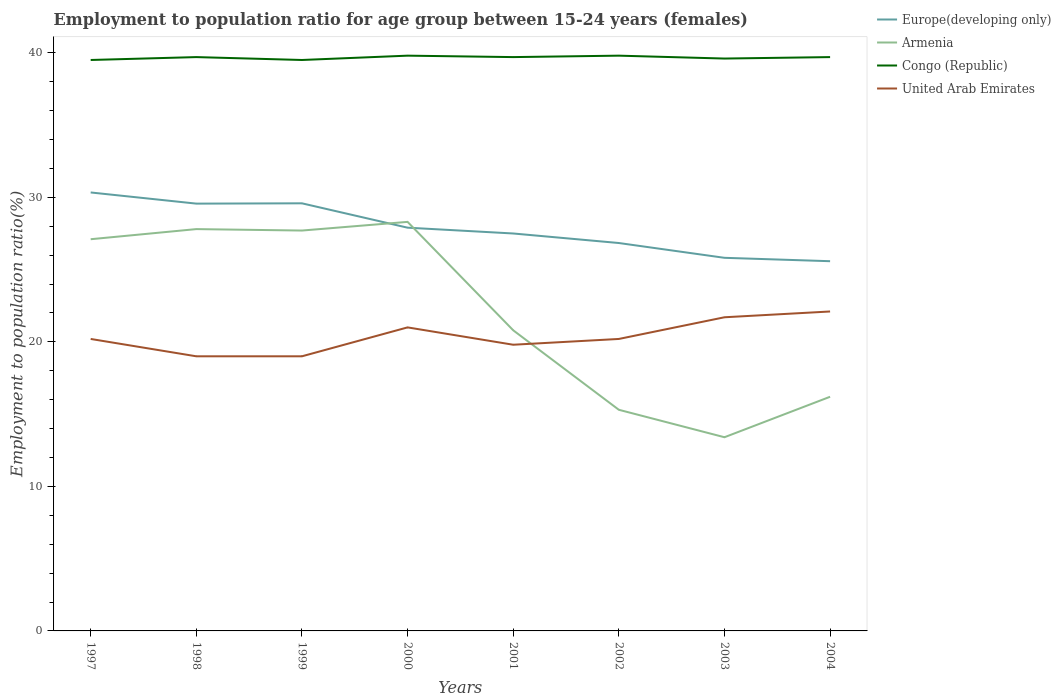How many different coloured lines are there?
Keep it short and to the point. 4. Is the number of lines equal to the number of legend labels?
Offer a terse response. Yes. Across all years, what is the maximum employment to population ratio in Armenia?
Keep it short and to the point. 13.4. What is the total employment to population ratio in Armenia in the graph?
Your answer should be very brief. 11.8. What is the difference between the highest and the second highest employment to population ratio in Europe(developing only)?
Keep it short and to the point. 4.76. How many lines are there?
Give a very brief answer. 4. Are the values on the major ticks of Y-axis written in scientific E-notation?
Offer a very short reply. No. How many legend labels are there?
Your answer should be compact. 4. What is the title of the graph?
Give a very brief answer. Employment to population ratio for age group between 15-24 years (females). Does "Seychelles" appear as one of the legend labels in the graph?
Provide a succinct answer. No. What is the label or title of the Y-axis?
Keep it short and to the point. Employment to population ratio(%). What is the Employment to population ratio(%) in Europe(developing only) in 1997?
Offer a very short reply. 30.33. What is the Employment to population ratio(%) of Armenia in 1997?
Keep it short and to the point. 27.1. What is the Employment to population ratio(%) in Congo (Republic) in 1997?
Provide a short and direct response. 39.5. What is the Employment to population ratio(%) of United Arab Emirates in 1997?
Your answer should be compact. 20.2. What is the Employment to population ratio(%) of Europe(developing only) in 1998?
Ensure brevity in your answer.  29.56. What is the Employment to population ratio(%) in Armenia in 1998?
Provide a succinct answer. 27.8. What is the Employment to population ratio(%) of Congo (Republic) in 1998?
Give a very brief answer. 39.7. What is the Employment to population ratio(%) of United Arab Emirates in 1998?
Provide a short and direct response. 19. What is the Employment to population ratio(%) of Europe(developing only) in 1999?
Make the answer very short. 29.58. What is the Employment to population ratio(%) in Armenia in 1999?
Your response must be concise. 27.7. What is the Employment to population ratio(%) of Congo (Republic) in 1999?
Give a very brief answer. 39.5. What is the Employment to population ratio(%) in Europe(developing only) in 2000?
Your answer should be very brief. 27.9. What is the Employment to population ratio(%) of Armenia in 2000?
Offer a very short reply. 28.3. What is the Employment to population ratio(%) in Congo (Republic) in 2000?
Your answer should be very brief. 39.8. What is the Employment to population ratio(%) in Europe(developing only) in 2001?
Your response must be concise. 27.5. What is the Employment to population ratio(%) of Armenia in 2001?
Provide a short and direct response. 20.8. What is the Employment to population ratio(%) in Congo (Republic) in 2001?
Ensure brevity in your answer.  39.7. What is the Employment to population ratio(%) of United Arab Emirates in 2001?
Your answer should be compact. 19.8. What is the Employment to population ratio(%) of Europe(developing only) in 2002?
Your answer should be very brief. 26.84. What is the Employment to population ratio(%) in Armenia in 2002?
Offer a very short reply. 15.3. What is the Employment to population ratio(%) of Congo (Republic) in 2002?
Offer a terse response. 39.8. What is the Employment to population ratio(%) in United Arab Emirates in 2002?
Offer a terse response. 20.2. What is the Employment to population ratio(%) in Europe(developing only) in 2003?
Provide a succinct answer. 25.81. What is the Employment to population ratio(%) of Armenia in 2003?
Ensure brevity in your answer.  13.4. What is the Employment to population ratio(%) of Congo (Republic) in 2003?
Offer a terse response. 39.6. What is the Employment to population ratio(%) of United Arab Emirates in 2003?
Give a very brief answer. 21.7. What is the Employment to population ratio(%) in Europe(developing only) in 2004?
Provide a short and direct response. 25.58. What is the Employment to population ratio(%) of Armenia in 2004?
Keep it short and to the point. 16.2. What is the Employment to population ratio(%) of Congo (Republic) in 2004?
Offer a very short reply. 39.7. What is the Employment to population ratio(%) of United Arab Emirates in 2004?
Ensure brevity in your answer.  22.1. Across all years, what is the maximum Employment to population ratio(%) in Europe(developing only)?
Your response must be concise. 30.33. Across all years, what is the maximum Employment to population ratio(%) of Armenia?
Give a very brief answer. 28.3. Across all years, what is the maximum Employment to population ratio(%) of Congo (Republic)?
Offer a very short reply. 39.8. Across all years, what is the maximum Employment to population ratio(%) of United Arab Emirates?
Keep it short and to the point. 22.1. Across all years, what is the minimum Employment to population ratio(%) in Europe(developing only)?
Your response must be concise. 25.58. Across all years, what is the minimum Employment to population ratio(%) of Armenia?
Give a very brief answer. 13.4. Across all years, what is the minimum Employment to population ratio(%) in Congo (Republic)?
Give a very brief answer. 39.5. Across all years, what is the minimum Employment to population ratio(%) of United Arab Emirates?
Your answer should be compact. 19. What is the total Employment to population ratio(%) in Europe(developing only) in the graph?
Provide a succinct answer. 223.11. What is the total Employment to population ratio(%) of Armenia in the graph?
Give a very brief answer. 176.6. What is the total Employment to population ratio(%) of Congo (Republic) in the graph?
Your answer should be very brief. 317.3. What is the total Employment to population ratio(%) of United Arab Emirates in the graph?
Ensure brevity in your answer.  163. What is the difference between the Employment to population ratio(%) of Europe(developing only) in 1997 and that in 1998?
Offer a very short reply. 0.77. What is the difference between the Employment to population ratio(%) of Congo (Republic) in 1997 and that in 1998?
Offer a very short reply. -0.2. What is the difference between the Employment to population ratio(%) of United Arab Emirates in 1997 and that in 1998?
Provide a short and direct response. 1.2. What is the difference between the Employment to population ratio(%) in Europe(developing only) in 1997 and that in 1999?
Give a very brief answer. 0.75. What is the difference between the Employment to population ratio(%) of Armenia in 1997 and that in 1999?
Offer a very short reply. -0.6. What is the difference between the Employment to population ratio(%) of Congo (Republic) in 1997 and that in 1999?
Ensure brevity in your answer.  0. What is the difference between the Employment to population ratio(%) of Europe(developing only) in 1997 and that in 2000?
Keep it short and to the point. 2.44. What is the difference between the Employment to population ratio(%) of Congo (Republic) in 1997 and that in 2000?
Provide a short and direct response. -0.3. What is the difference between the Employment to population ratio(%) of Europe(developing only) in 1997 and that in 2001?
Your answer should be compact. 2.84. What is the difference between the Employment to population ratio(%) in Armenia in 1997 and that in 2001?
Provide a short and direct response. 6.3. What is the difference between the Employment to population ratio(%) of United Arab Emirates in 1997 and that in 2001?
Provide a succinct answer. 0.4. What is the difference between the Employment to population ratio(%) of Europe(developing only) in 1997 and that in 2002?
Your response must be concise. 3.5. What is the difference between the Employment to population ratio(%) in Armenia in 1997 and that in 2002?
Offer a terse response. 11.8. What is the difference between the Employment to population ratio(%) in Congo (Republic) in 1997 and that in 2002?
Your answer should be very brief. -0.3. What is the difference between the Employment to population ratio(%) of Europe(developing only) in 1997 and that in 2003?
Offer a terse response. 4.52. What is the difference between the Employment to population ratio(%) in Europe(developing only) in 1997 and that in 2004?
Provide a short and direct response. 4.76. What is the difference between the Employment to population ratio(%) of United Arab Emirates in 1997 and that in 2004?
Offer a terse response. -1.9. What is the difference between the Employment to population ratio(%) of Europe(developing only) in 1998 and that in 1999?
Your answer should be compact. -0.02. What is the difference between the Employment to population ratio(%) in Europe(developing only) in 1998 and that in 2000?
Keep it short and to the point. 1.66. What is the difference between the Employment to population ratio(%) of Congo (Republic) in 1998 and that in 2000?
Provide a short and direct response. -0.1. What is the difference between the Employment to population ratio(%) of United Arab Emirates in 1998 and that in 2000?
Provide a short and direct response. -2. What is the difference between the Employment to population ratio(%) of Europe(developing only) in 1998 and that in 2001?
Keep it short and to the point. 2.07. What is the difference between the Employment to population ratio(%) in Europe(developing only) in 1998 and that in 2002?
Provide a short and direct response. 2.73. What is the difference between the Employment to population ratio(%) of United Arab Emirates in 1998 and that in 2002?
Offer a very short reply. -1.2. What is the difference between the Employment to population ratio(%) in Europe(developing only) in 1998 and that in 2003?
Your response must be concise. 3.75. What is the difference between the Employment to population ratio(%) in Congo (Republic) in 1998 and that in 2003?
Give a very brief answer. 0.1. What is the difference between the Employment to population ratio(%) of United Arab Emirates in 1998 and that in 2003?
Ensure brevity in your answer.  -2.7. What is the difference between the Employment to population ratio(%) in Europe(developing only) in 1998 and that in 2004?
Give a very brief answer. 3.98. What is the difference between the Employment to population ratio(%) of Congo (Republic) in 1998 and that in 2004?
Give a very brief answer. 0. What is the difference between the Employment to population ratio(%) of Europe(developing only) in 1999 and that in 2000?
Provide a short and direct response. 1.69. What is the difference between the Employment to population ratio(%) of Armenia in 1999 and that in 2000?
Provide a succinct answer. -0.6. What is the difference between the Employment to population ratio(%) in Europe(developing only) in 1999 and that in 2001?
Your response must be concise. 2.09. What is the difference between the Employment to population ratio(%) of Congo (Republic) in 1999 and that in 2001?
Keep it short and to the point. -0.2. What is the difference between the Employment to population ratio(%) of United Arab Emirates in 1999 and that in 2001?
Your answer should be very brief. -0.8. What is the difference between the Employment to population ratio(%) of Europe(developing only) in 1999 and that in 2002?
Provide a short and direct response. 2.75. What is the difference between the Employment to population ratio(%) of United Arab Emirates in 1999 and that in 2002?
Make the answer very short. -1.2. What is the difference between the Employment to population ratio(%) of Europe(developing only) in 1999 and that in 2003?
Ensure brevity in your answer.  3.77. What is the difference between the Employment to population ratio(%) of Armenia in 1999 and that in 2003?
Keep it short and to the point. 14.3. What is the difference between the Employment to population ratio(%) in Congo (Republic) in 1999 and that in 2003?
Give a very brief answer. -0.1. What is the difference between the Employment to population ratio(%) of United Arab Emirates in 1999 and that in 2003?
Your answer should be compact. -2.7. What is the difference between the Employment to population ratio(%) in Europe(developing only) in 1999 and that in 2004?
Make the answer very short. 4.01. What is the difference between the Employment to population ratio(%) in Armenia in 1999 and that in 2004?
Give a very brief answer. 11.5. What is the difference between the Employment to population ratio(%) of Congo (Republic) in 1999 and that in 2004?
Make the answer very short. -0.2. What is the difference between the Employment to population ratio(%) of United Arab Emirates in 1999 and that in 2004?
Your answer should be very brief. -3.1. What is the difference between the Employment to population ratio(%) in Europe(developing only) in 2000 and that in 2001?
Your answer should be compact. 0.4. What is the difference between the Employment to population ratio(%) of Armenia in 2000 and that in 2001?
Provide a short and direct response. 7.5. What is the difference between the Employment to population ratio(%) of Europe(developing only) in 2000 and that in 2002?
Give a very brief answer. 1.06. What is the difference between the Employment to population ratio(%) of Congo (Republic) in 2000 and that in 2002?
Make the answer very short. 0. What is the difference between the Employment to population ratio(%) of Europe(developing only) in 2000 and that in 2003?
Ensure brevity in your answer.  2.08. What is the difference between the Employment to population ratio(%) in Armenia in 2000 and that in 2003?
Your response must be concise. 14.9. What is the difference between the Employment to population ratio(%) of Europe(developing only) in 2000 and that in 2004?
Offer a terse response. 2.32. What is the difference between the Employment to population ratio(%) of Armenia in 2000 and that in 2004?
Your response must be concise. 12.1. What is the difference between the Employment to population ratio(%) of Europe(developing only) in 2001 and that in 2002?
Your response must be concise. 0.66. What is the difference between the Employment to population ratio(%) of Congo (Republic) in 2001 and that in 2002?
Offer a very short reply. -0.1. What is the difference between the Employment to population ratio(%) in Europe(developing only) in 2001 and that in 2003?
Make the answer very short. 1.68. What is the difference between the Employment to population ratio(%) in Congo (Republic) in 2001 and that in 2003?
Give a very brief answer. 0.1. What is the difference between the Employment to population ratio(%) in Europe(developing only) in 2001 and that in 2004?
Offer a very short reply. 1.92. What is the difference between the Employment to population ratio(%) in United Arab Emirates in 2001 and that in 2004?
Offer a terse response. -2.3. What is the difference between the Employment to population ratio(%) of Europe(developing only) in 2002 and that in 2003?
Ensure brevity in your answer.  1.02. What is the difference between the Employment to population ratio(%) of Armenia in 2002 and that in 2003?
Keep it short and to the point. 1.9. What is the difference between the Employment to population ratio(%) of Europe(developing only) in 2002 and that in 2004?
Keep it short and to the point. 1.26. What is the difference between the Employment to population ratio(%) of Europe(developing only) in 2003 and that in 2004?
Your response must be concise. 0.23. What is the difference between the Employment to population ratio(%) of Armenia in 2003 and that in 2004?
Your answer should be very brief. -2.8. What is the difference between the Employment to population ratio(%) in Europe(developing only) in 1997 and the Employment to population ratio(%) in Armenia in 1998?
Ensure brevity in your answer.  2.53. What is the difference between the Employment to population ratio(%) of Europe(developing only) in 1997 and the Employment to population ratio(%) of Congo (Republic) in 1998?
Give a very brief answer. -9.37. What is the difference between the Employment to population ratio(%) of Europe(developing only) in 1997 and the Employment to population ratio(%) of United Arab Emirates in 1998?
Your answer should be very brief. 11.33. What is the difference between the Employment to population ratio(%) in Armenia in 1997 and the Employment to population ratio(%) in Congo (Republic) in 1998?
Give a very brief answer. -12.6. What is the difference between the Employment to population ratio(%) in Congo (Republic) in 1997 and the Employment to population ratio(%) in United Arab Emirates in 1998?
Provide a short and direct response. 20.5. What is the difference between the Employment to population ratio(%) in Europe(developing only) in 1997 and the Employment to population ratio(%) in Armenia in 1999?
Give a very brief answer. 2.63. What is the difference between the Employment to population ratio(%) of Europe(developing only) in 1997 and the Employment to population ratio(%) of Congo (Republic) in 1999?
Provide a short and direct response. -9.17. What is the difference between the Employment to population ratio(%) in Europe(developing only) in 1997 and the Employment to population ratio(%) in United Arab Emirates in 1999?
Ensure brevity in your answer.  11.33. What is the difference between the Employment to population ratio(%) of Armenia in 1997 and the Employment to population ratio(%) of Congo (Republic) in 1999?
Your answer should be very brief. -12.4. What is the difference between the Employment to population ratio(%) of Armenia in 1997 and the Employment to population ratio(%) of United Arab Emirates in 1999?
Offer a very short reply. 8.1. What is the difference between the Employment to population ratio(%) of Europe(developing only) in 1997 and the Employment to population ratio(%) of Armenia in 2000?
Offer a very short reply. 2.03. What is the difference between the Employment to population ratio(%) of Europe(developing only) in 1997 and the Employment to population ratio(%) of Congo (Republic) in 2000?
Ensure brevity in your answer.  -9.47. What is the difference between the Employment to population ratio(%) in Europe(developing only) in 1997 and the Employment to population ratio(%) in United Arab Emirates in 2000?
Offer a very short reply. 9.33. What is the difference between the Employment to population ratio(%) of Armenia in 1997 and the Employment to population ratio(%) of Congo (Republic) in 2000?
Offer a very short reply. -12.7. What is the difference between the Employment to population ratio(%) in Europe(developing only) in 1997 and the Employment to population ratio(%) in Armenia in 2001?
Offer a terse response. 9.53. What is the difference between the Employment to population ratio(%) of Europe(developing only) in 1997 and the Employment to population ratio(%) of Congo (Republic) in 2001?
Provide a succinct answer. -9.37. What is the difference between the Employment to population ratio(%) of Europe(developing only) in 1997 and the Employment to population ratio(%) of United Arab Emirates in 2001?
Give a very brief answer. 10.53. What is the difference between the Employment to population ratio(%) in Armenia in 1997 and the Employment to population ratio(%) in United Arab Emirates in 2001?
Your answer should be very brief. 7.3. What is the difference between the Employment to population ratio(%) of Congo (Republic) in 1997 and the Employment to population ratio(%) of United Arab Emirates in 2001?
Keep it short and to the point. 19.7. What is the difference between the Employment to population ratio(%) in Europe(developing only) in 1997 and the Employment to population ratio(%) in Armenia in 2002?
Provide a succinct answer. 15.03. What is the difference between the Employment to population ratio(%) in Europe(developing only) in 1997 and the Employment to population ratio(%) in Congo (Republic) in 2002?
Ensure brevity in your answer.  -9.47. What is the difference between the Employment to population ratio(%) of Europe(developing only) in 1997 and the Employment to population ratio(%) of United Arab Emirates in 2002?
Make the answer very short. 10.13. What is the difference between the Employment to population ratio(%) of Armenia in 1997 and the Employment to population ratio(%) of United Arab Emirates in 2002?
Provide a short and direct response. 6.9. What is the difference between the Employment to population ratio(%) of Congo (Republic) in 1997 and the Employment to population ratio(%) of United Arab Emirates in 2002?
Provide a succinct answer. 19.3. What is the difference between the Employment to population ratio(%) of Europe(developing only) in 1997 and the Employment to population ratio(%) of Armenia in 2003?
Offer a very short reply. 16.93. What is the difference between the Employment to population ratio(%) in Europe(developing only) in 1997 and the Employment to population ratio(%) in Congo (Republic) in 2003?
Your answer should be very brief. -9.27. What is the difference between the Employment to population ratio(%) of Europe(developing only) in 1997 and the Employment to population ratio(%) of United Arab Emirates in 2003?
Ensure brevity in your answer.  8.63. What is the difference between the Employment to population ratio(%) in Armenia in 1997 and the Employment to population ratio(%) in Congo (Republic) in 2003?
Provide a short and direct response. -12.5. What is the difference between the Employment to population ratio(%) of Armenia in 1997 and the Employment to population ratio(%) of United Arab Emirates in 2003?
Provide a short and direct response. 5.4. What is the difference between the Employment to population ratio(%) in Congo (Republic) in 1997 and the Employment to population ratio(%) in United Arab Emirates in 2003?
Keep it short and to the point. 17.8. What is the difference between the Employment to population ratio(%) of Europe(developing only) in 1997 and the Employment to population ratio(%) of Armenia in 2004?
Ensure brevity in your answer.  14.13. What is the difference between the Employment to population ratio(%) of Europe(developing only) in 1997 and the Employment to population ratio(%) of Congo (Republic) in 2004?
Ensure brevity in your answer.  -9.37. What is the difference between the Employment to population ratio(%) in Europe(developing only) in 1997 and the Employment to population ratio(%) in United Arab Emirates in 2004?
Provide a short and direct response. 8.23. What is the difference between the Employment to population ratio(%) in Armenia in 1997 and the Employment to population ratio(%) in Congo (Republic) in 2004?
Give a very brief answer. -12.6. What is the difference between the Employment to population ratio(%) of Armenia in 1997 and the Employment to population ratio(%) of United Arab Emirates in 2004?
Make the answer very short. 5. What is the difference between the Employment to population ratio(%) in Europe(developing only) in 1998 and the Employment to population ratio(%) in Armenia in 1999?
Provide a short and direct response. 1.86. What is the difference between the Employment to population ratio(%) in Europe(developing only) in 1998 and the Employment to population ratio(%) in Congo (Republic) in 1999?
Your answer should be compact. -9.94. What is the difference between the Employment to population ratio(%) of Europe(developing only) in 1998 and the Employment to population ratio(%) of United Arab Emirates in 1999?
Keep it short and to the point. 10.56. What is the difference between the Employment to population ratio(%) in Armenia in 1998 and the Employment to population ratio(%) in Congo (Republic) in 1999?
Your response must be concise. -11.7. What is the difference between the Employment to population ratio(%) of Congo (Republic) in 1998 and the Employment to population ratio(%) of United Arab Emirates in 1999?
Provide a short and direct response. 20.7. What is the difference between the Employment to population ratio(%) in Europe(developing only) in 1998 and the Employment to population ratio(%) in Armenia in 2000?
Your answer should be compact. 1.26. What is the difference between the Employment to population ratio(%) of Europe(developing only) in 1998 and the Employment to population ratio(%) of Congo (Republic) in 2000?
Your answer should be compact. -10.24. What is the difference between the Employment to population ratio(%) of Europe(developing only) in 1998 and the Employment to population ratio(%) of United Arab Emirates in 2000?
Provide a short and direct response. 8.56. What is the difference between the Employment to population ratio(%) of Armenia in 1998 and the Employment to population ratio(%) of Congo (Republic) in 2000?
Provide a short and direct response. -12. What is the difference between the Employment to population ratio(%) of Armenia in 1998 and the Employment to population ratio(%) of United Arab Emirates in 2000?
Your answer should be very brief. 6.8. What is the difference between the Employment to population ratio(%) in Congo (Republic) in 1998 and the Employment to population ratio(%) in United Arab Emirates in 2000?
Keep it short and to the point. 18.7. What is the difference between the Employment to population ratio(%) in Europe(developing only) in 1998 and the Employment to population ratio(%) in Armenia in 2001?
Your answer should be very brief. 8.76. What is the difference between the Employment to population ratio(%) in Europe(developing only) in 1998 and the Employment to population ratio(%) in Congo (Republic) in 2001?
Make the answer very short. -10.14. What is the difference between the Employment to population ratio(%) in Europe(developing only) in 1998 and the Employment to population ratio(%) in United Arab Emirates in 2001?
Ensure brevity in your answer.  9.76. What is the difference between the Employment to population ratio(%) of Congo (Republic) in 1998 and the Employment to population ratio(%) of United Arab Emirates in 2001?
Provide a short and direct response. 19.9. What is the difference between the Employment to population ratio(%) of Europe(developing only) in 1998 and the Employment to population ratio(%) of Armenia in 2002?
Your answer should be very brief. 14.26. What is the difference between the Employment to population ratio(%) of Europe(developing only) in 1998 and the Employment to population ratio(%) of Congo (Republic) in 2002?
Give a very brief answer. -10.24. What is the difference between the Employment to population ratio(%) in Europe(developing only) in 1998 and the Employment to population ratio(%) in United Arab Emirates in 2002?
Provide a short and direct response. 9.36. What is the difference between the Employment to population ratio(%) of Armenia in 1998 and the Employment to population ratio(%) of United Arab Emirates in 2002?
Offer a very short reply. 7.6. What is the difference between the Employment to population ratio(%) of Congo (Republic) in 1998 and the Employment to population ratio(%) of United Arab Emirates in 2002?
Your answer should be compact. 19.5. What is the difference between the Employment to population ratio(%) of Europe(developing only) in 1998 and the Employment to population ratio(%) of Armenia in 2003?
Keep it short and to the point. 16.16. What is the difference between the Employment to population ratio(%) in Europe(developing only) in 1998 and the Employment to population ratio(%) in Congo (Republic) in 2003?
Provide a short and direct response. -10.04. What is the difference between the Employment to population ratio(%) of Europe(developing only) in 1998 and the Employment to population ratio(%) of United Arab Emirates in 2003?
Make the answer very short. 7.86. What is the difference between the Employment to population ratio(%) in Europe(developing only) in 1998 and the Employment to population ratio(%) in Armenia in 2004?
Your answer should be compact. 13.36. What is the difference between the Employment to population ratio(%) of Europe(developing only) in 1998 and the Employment to population ratio(%) of Congo (Republic) in 2004?
Ensure brevity in your answer.  -10.14. What is the difference between the Employment to population ratio(%) in Europe(developing only) in 1998 and the Employment to population ratio(%) in United Arab Emirates in 2004?
Your answer should be compact. 7.46. What is the difference between the Employment to population ratio(%) of Armenia in 1998 and the Employment to population ratio(%) of Congo (Republic) in 2004?
Provide a succinct answer. -11.9. What is the difference between the Employment to population ratio(%) of Armenia in 1998 and the Employment to population ratio(%) of United Arab Emirates in 2004?
Offer a terse response. 5.7. What is the difference between the Employment to population ratio(%) in Congo (Republic) in 1998 and the Employment to population ratio(%) in United Arab Emirates in 2004?
Offer a terse response. 17.6. What is the difference between the Employment to population ratio(%) in Europe(developing only) in 1999 and the Employment to population ratio(%) in Armenia in 2000?
Offer a terse response. 1.28. What is the difference between the Employment to population ratio(%) in Europe(developing only) in 1999 and the Employment to population ratio(%) in Congo (Republic) in 2000?
Your response must be concise. -10.22. What is the difference between the Employment to population ratio(%) of Europe(developing only) in 1999 and the Employment to population ratio(%) of United Arab Emirates in 2000?
Your answer should be very brief. 8.58. What is the difference between the Employment to population ratio(%) in Armenia in 1999 and the Employment to population ratio(%) in United Arab Emirates in 2000?
Give a very brief answer. 6.7. What is the difference between the Employment to population ratio(%) of Europe(developing only) in 1999 and the Employment to population ratio(%) of Armenia in 2001?
Ensure brevity in your answer.  8.78. What is the difference between the Employment to population ratio(%) of Europe(developing only) in 1999 and the Employment to population ratio(%) of Congo (Republic) in 2001?
Offer a very short reply. -10.12. What is the difference between the Employment to population ratio(%) of Europe(developing only) in 1999 and the Employment to population ratio(%) of United Arab Emirates in 2001?
Give a very brief answer. 9.78. What is the difference between the Employment to population ratio(%) in Armenia in 1999 and the Employment to population ratio(%) in United Arab Emirates in 2001?
Your answer should be very brief. 7.9. What is the difference between the Employment to population ratio(%) of Europe(developing only) in 1999 and the Employment to population ratio(%) of Armenia in 2002?
Offer a terse response. 14.28. What is the difference between the Employment to population ratio(%) in Europe(developing only) in 1999 and the Employment to population ratio(%) in Congo (Republic) in 2002?
Your answer should be very brief. -10.22. What is the difference between the Employment to population ratio(%) in Europe(developing only) in 1999 and the Employment to population ratio(%) in United Arab Emirates in 2002?
Keep it short and to the point. 9.38. What is the difference between the Employment to population ratio(%) in Armenia in 1999 and the Employment to population ratio(%) in United Arab Emirates in 2002?
Your response must be concise. 7.5. What is the difference between the Employment to population ratio(%) of Congo (Republic) in 1999 and the Employment to population ratio(%) of United Arab Emirates in 2002?
Make the answer very short. 19.3. What is the difference between the Employment to population ratio(%) of Europe(developing only) in 1999 and the Employment to population ratio(%) of Armenia in 2003?
Offer a very short reply. 16.18. What is the difference between the Employment to population ratio(%) in Europe(developing only) in 1999 and the Employment to population ratio(%) in Congo (Republic) in 2003?
Make the answer very short. -10.02. What is the difference between the Employment to population ratio(%) of Europe(developing only) in 1999 and the Employment to population ratio(%) of United Arab Emirates in 2003?
Give a very brief answer. 7.88. What is the difference between the Employment to population ratio(%) in Europe(developing only) in 1999 and the Employment to population ratio(%) in Armenia in 2004?
Offer a very short reply. 13.38. What is the difference between the Employment to population ratio(%) in Europe(developing only) in 1999 and the Employment to population ratio(%) in Congo (Republic) in 2004?
Offer a very short reply. -10.12. What is the difference between the Employment to population ratio(%) in Europe(developing only) in 1999 and the Employment to population ratio(%) in United Arab Emirates in 2004?
Make the answer very short. 7.48. What is the difference between the Employment to population ratio(%) of Armenia in 1999 and the Employment to population ratio(%) of Congo (Republic) in 2004?
Give a very brief answer. -12. What is the difference between the Employment to population ratio(%) in Armenia in 1999 and the Employment to population ratio(%) in United Arab Emirates in 2004?
Give a very brief answer. 5.6. What is the difference between the Employment to population ratio(%) in Congo (Republic) in 1999 and the Employment to population ratio(%) in United Arab Emirates in 2004?
Make the answer very short. 17.4. What is the difference between the Employment to population ratio(%) of Europe(developing only) in 2000 and the Employment to population ratio(%) of Armenia in 2001?
Ensure brevity in your answer.  7.1. What is the difference between the Employment to population ratio(%) in Europe(developing only) in 2000 and the Employment to population ratio(%) in Congo (Republic) in 2001?
Provide a succinct answer. -11.8. What is the difference between the Employment to population ratio(%) of Europe(developing only) in 2000 and the Employment to population ratio(%) of United Arab Emirates in 2001?
Your answer should be compact. 8.1. What is the difference between the Employment to population ratio(%) in Congo (Republic) in 2000 and the Employment to population ratio(%) in United Arab Emirates in 2001?
Ensure brevity in your answer.  20. What is the difference between the Employment to population ratio(%) of Europe(developing only) in 2000 and the Employment to population ratio(%) of Armenia in 2002?
Offer a terse response. 12.6. What is the difference between the Employment to population ratio(%) in Europe(developing only) in 2000 and the Employment to population ratio(%) in Congo (Republic) in 2002?
Provide a short and direct response. -11.9. What is the difference between the Employment to population ratio(%) in Europe(developing only) in 2000 and the Employment to population ratio(%) in United Arab Emirates in 2002?
Provide a short and direct response. 7.7. What is the difference between the Employment to population ratio(%) in Armenia in 2000 and the Employment to population ratio(%) in Congo (Republic) in 2002?
Offer a terse response. -11.5. What is the difference between the Employment to population ratio(%) of Congo (Republic) in 2000 and the Employment to population ratio(%) of United Arab Emirates in 2002?
Provide a succinct answer. 19.6. What is the difference between the Employment to population ratio(%) of Europe(developing only) in 2000 and the Employment to population ratio(%) of Armenia in 2003?
Ensure brevity in your answer.  14.5. What is the difference between the Employment to population ratio(%) in Europe(developing only) in 2000 and the Employment to population ratio(%) in Congo (Republic) in 2003?
Give a very brief answer. -11.7. What is the difference between the Employment to population ratio(%) of Europe(developing only) in 2000 and the Employment to population ratio(%) of United Arab Emirates in 2003?
Provide a short and direct response. 6.2. What is the difference between the Employment to population ratio(%) in Armenia in 2000 and the Employment to population ratio(%) in Congo (Republic) in 2003?
Provide a short and direct response. -11.3. What is the difference between the Employment to population ratio(%) of Congo (Republic) in 2000 and the Employment to population ratio(%) of United Arab Emirates in 2003?
Keep it short and to the point. 18.1. What is the difference between the Employment to population ratio(%) of Europe(developing only) in 2000 and the Employment to population ratio(%) of Armenia in 2004?
Provide a succinct answer. 11.7. What is the difference between the Employment to population ratio(%) of Europe(developing only) in 2000 and the Employment to population ratio(%) of Congo (Republic) in 2004?
Offer a very short reply. -11.8. What is the difference between the Employment to population ratio(%) in Europe(developing only) in 2000 and the Employment to population ratio(%) in United Arab Emirates in 2004?
Provide a succinct answer. 5.8. What is the difference between the Employment to population ratio(%) of Armenia in 2000 and the Employment to population ratio(%) of Congo (Republic) in 2004?
Provide a short and direct response. -11.4. What is the difference between the Employment to population ratio(%) in Armenia in 2000 and the Employment to population ratio(%) in United Arab Emirates in 2004?
Offer a very short reply. 6.2. What is the difference between the Employment to population ratio(%) in Europe(developing only) in 2001 and the Employment to population ratio(%) in Armenia in 2002?
Give a very brief answer. 12.2. What is the difference between the Employment to population ratio(%) of Europe(developing only) in 2001 and the Employment to population ratio(%) of Congo (Republic) in 2002?
Keep it short and to the point. -12.3. What is the difference between the Employment to population ratio(%) of Europe(developing only) in 2001 and the Employment to population ratio(%) of United Arab Emirates in 2002?
Your answer should be compact. 7.3. What is the difference between the Employment to population ratio(%) of Armenia in 2001 and the Employment to population ratio(%) of United Arab Emirates in 2002?
Your answer should be very brief. 0.6. What is the difference between the Employment to population ratio(%) in Congo (Republic) in 2001 and the Employment to population ratio(%) in United Arab Emirates in 2002?
Keep it short and to the point. 19.5. What is the difference between the Employment to population ratio(%) of Europe(developing only) in 2001 and the Employment to population ratio(%) of Armenia in 2003?
Offer a very short reply. 14.1. What is the difference between the Employment to population ratio(%) of Europe(developing only) in 2001 and the Employment to population ratio(%) of Congo (Republic) in 2003?
Give a very brief answer. -12.1. What is the difference between the Employment to population ratio(%) of Europe(developing only) in 2001 and the Employment to population ratio(%) of United Arab Emirates in 2003?
Ensure brevity in your answer.  5.8. What is the difference between the Employment to population ratio(%) in Armenia in 2001 and the Employment to population ratio(%) in Congo (Republic) in 2003?
Offer a very short reply. -18.8. What is the difference between the Employment to population ratio(%) in Congo (Republic) in 2001 and the Employment to population ratio(%) in United Arab Emirates in 2003?
Provide a short and direct response. 18. What is the difference between the Employment to population ratio(%) in Europe(developing only) in 2001 and the Employment to population ratio(%) in Armenia in 2004?
Offer a very short reply. 11.3. What is the difference between the Employment to population ratio(%) in Europe(developing only) in 2001 and the Employment to population ratio(%) in Congo (Republic) in 2004?
Your response must be concise. -12.2. What is the difference between the Employment to population ratio(%) in Europe(developing only) in 2001 and the Employment to population ratio(%) in United Arab Emirates in 2004?
Give a very brief answer. 5.4. What is the difference between the Employment to population ratio(%) in Armenia in 2001 and the Employment to population ratio(%) in Congo (Republic) in 2004?
Keep it short and to the point. -18.9. What is the difference between the Employment to population ratio(%) in Congo (Republic) in 2001 and the Employment to population ratio(%) in United Arab Emirates in 2004?
Your answer should be very brief. 17.6. What is the difference between the Employment to population ratio(%) of Europe(developing only) in 2002 and the Employment to population ratio(%) of Armenia in 2003?
Give a very brief answer. 13.44. What is the difference between the Employment to population ratio(%) in Europe(developing only) in 2002 and the Employment to population ratio(%) in Congo (Republic) in 2003?
Ensure brevity in your answer.  -12.76. What is the difference between the Employment to population ratio(%) of Europe(developing only) in 2002 and the Employment to population ratio(%) of United Arab Emirates in 2003?
Provide a short and direct response. 5.14. What is the difference between the Employment to population ratio(%) in Armenia in 2002 and the Employment to population ratio(%) in Congo (Republic) in 2003?
Ensure brevity in your answer.  -24.3. What is the difference between the Employment to population ratio(%) of Armenia in 2002 and the Employment to population ratio(%) of United Arab Emirates in 2003?
Make the answer very short. -6.4. What is the difference between the Employment to population ratio(%) of Europe(developing only) in 2002 and the Employment to population ratio(%) of Armenia in 2004?
Your response must be concise. 10.64. What is the difference between the Employment to population ratio(%) in Europe(developing only) in 2002 and the Employment to population ratio(%) in Congo (Republic) in 2004?
Your answer should be very brief. -12.86. What is the difference between the Employment to population ratio(%) in Europe(developing only) in 2002 and the Employment to population ratio(%) in United Arab Emirates in 2004?
Your answer should be compact. 4.74. What is the difference between the Employment to population ratio(%) in Armenia in 2002 and the Employment to population ratio(%) in Congo (Republic) in 2004?
Give a very brief answer. -24.4. What is the difference between the Employment to population ratio(%) of Europe(developing only) in 2003 and the Employment to population ratio(%) of Armenia in 2004?
Ensure brevity in your answer.  9.61. What is the difference between the Employment to population ratio(%) in Europe(developing only) in 2003 and the Employment to population ratio(%) in Congo (Republic) in 2004?
Your response must be concise. -13.89. What is the difference between the Employment to population ratio(%) in Europe(developing only) in 2003 and the Employment to population ratio(%) in United Arab Emirates in 2004?
Offer a very short reply. 3.71. What is the difference between the Employment to population ratio(%) in Armenia in 2003 and the Employment to population ratio(%) in Congo (Republic) in 2004?
Offer a very short reply. -26.3. What is the average Employment to population ratio(%) of Europe(developing only) per year?
Your answer should be very brief. 27.89. What is the average Employment to population ratio(%) in Armenia per year?
Keep it short and to the point. 22.07. What is the average Employment to population ratio(%) of Congo (Republic) per year?
Your response must be concise. 39.66. What is the average Employment to population ratio(%) of United Arab Emirates per year?
Your response must be concise. 20.38. In the year 1997, what is the difference between the Employment to population ratio(%) in Europe(developing only) and Employment to population ratio(%) in Armenia?
Make the answer very short. 3.23. In the year 1997, what is the difference between the Employment to population ratio(%) of Europe(developing only) and Employment to population ratio(%) of Congo (Republic)?
Ensure brevity in your answer.  -9.17. In the year 1997, what is the difference between the Employment to population ratio(%) of Europe(developing only) and Employment to population ratio(%) of United Arab Emirates?
Offer a very short reply. 10.13. In the year 1997, what is the difference between the Employment to population ratio(%) in Congo (Republic) and Employment to population ratio(%) in United Arab Emirates?
Your response must be concise. 19.3. In the year 1998, what is the difference between the Employment to population ratio(%) of Europe(developing only) and Employment to population ratio(%) of Armenia?
Offer a very short reply. 1.76. In the year 1998, what is the difference between the Employment to population ratio(%) of Europe(developing only) and Employment to population ratio(%) of Congo (Republic)?
Your answer should be compact. -10.14. In the year 1998, what is the difference between the Employment to population ratio(%) of Europe(developing only) and Employment to population ratio(%) of United Arab Emirates?
Your answer should be very brief. 10.56. In the year 1998, what is the difference between the Employment to population ratio(%) of Armenia and Employment to population ratio(%) of Congo (Republic)?
Provide a short and direct response. -11.9. In the year 1998, what is the difference between the Employment to population ratio(%) of Armenia and Employment to population ratio(%) of United Arab Emirates?
Keep it short and to the point. 8.8. In the year 1998, what is the difference between the Employment to population ratio(%) of Congo (Republic) and Employment to population ratio(%) of United Arab Emirates?
Offer a terse response. 20.7. In the year 1999, what is the difference between the Employment to population ratio(%) of Europe(developing only) and Employment to population ratio(%) of Armenia?
Offer a terse response. 1.88. In the year 1999, what is the difference between the Employment to population ratio(%) in Europe(developing only) and Employment to population ratio(%) in Congo (Republic)?
Provide a succinct answer. -9.92. In the year 1999, what is the difference between the Employment to population ratio(%) of Europe(developing only) and Employment to population ratio(%) of United Arab Emirates?
Your answer should be compact. 10.58. In the year 2000, what is the difference between the Employment to population ratio(%) in Europe(developing only) and Employment to population ratio(%) in Armenia?
Offer a very short reply. -0.4. In the year 2000, what is the difference between the Employment to population ratio(%) in Europe(developing only) and Employment to population ratio(%) in Congo (Republic)?
Your answer should be compact. -11.9. In the year 2000, what is the difference between the Employment to population ratio(%) of Europe(developing only) and Employment to population ratio(%) of United Arab Emirates?
Give a very brief answer. 6.9. In the year 2000, what is the difference between the Employment to population ratio(%) in Armenia and Employment to population ratio(%) in Congo (Republic)?
Keep it short and to the point. -11.5. In the year 2000, what is the difference between the Employment to population ratio(%) in Armenia and Employment to population ratio(%) in United Arab Emirates?
Your answer should be compact. 7.3. In the year 2001, what is the difference between the Employment to population ratio(%) of Europe(developing only) and Employment to population ratio(%) of Armenia?
Ensure brevity in your answer.  6.7. In the year 2001, what is the difference between the Employment to population ratio(%) of Europe(developing only) and Employment to population ratio(%) of Congo (Republic)?
Provide a short and direct response. -12.2. In the year 2001, what is the difference between the Employment to population ratio(%) in Europe(developing only) and Employment to population ratio(%) in United Arab Emirates?
Keep it short and to the point. 7.7. In the year 2001, what is the difference between the Employment to population ratio(%) of Armenia and Employment to population ratio(%) of Congo (Republic)?
Give a very brief answer. -18.9. In the year 2001, what is the difference between the Employment to population ratio(%) in Congo (Republic) and Employment to population ratio(%) in United Arab Emirates?
Make the answer very short. 19.9. In the year 2002, what is the difference between the Employment to population ratio(%) in Europe(developing only) and Employment to population ratio(%) in Armenia?
Offer a terse response. 11.54. In the year 2002, what is the difference between the Employment to population ratio(%) in Europe(developing only) and Employment to population ratio(%) in Congo (Republic)?
Make the answer very short. -12.96. In the year 2002, what is the difference between the Employment to population ratio(%) in Europe(developing only) and Employment to population ratio(%) in United Arab Emirates?
Offer a very short reply. 6.64. In the year 2002, what is the difference between the Employment to population ratio(%) in Armenia and Employment to population ratio(%) in Congo (Republic)?
Your answer should be compact. -24.5. In the year 2002, what is the difference between the Employment to population ratio(%) in Armenia and Employment to population ratio(%) in United Arab Emirates?
Provide a succinct answer. -4.9. In the year 2002, what is the difference between the Employment to population ratio(%) of Congo (Republic) and Employment to population ratio(%) of United Arab Emirates?
Keep it short and to the point. 19.6. In the year 2003, what is the difference between the Employment to population ratio(%) in Europe(developing only) and Employment to population ratio(%) in Armenia?
Offer a very short reply. 12.41. In the year 2003, what is the difference between the Employment to population ratio(%) of Europe(developing only) and Employment to population ratio(%) of Congo (Republic)?
Your answer should be very brief. -13.79. In the year 2003, what is the difference between the Employment to population ratio(%) of Europe(developing only) and Employment to population ratio(%) of United Arab Emirates?
Make the answer very short. 4.11. In the year 2003, what is the difference between the Employment to population ratio(%) in Armenia and Employment to population ratio(%) in Congo (Republic)?
Provide a succinct answer. -26.2. In the year 2003, what is the difference between the Employment to population ratio(%) in Congo (Republic) and Employment to population ratio(%) in United Arab Emirates?
Ensure brevity in your answer.  17.9. In the year 2004, what is the difference between the Employment to population ratio(%) of Europe(developing only) and Employment to population ratio(%) of Armenia?
Give a very brief answer. 9.38. In the year 2004, what is the difference between the Employment to population ratio(%) in Europe(developing only) and Employment to population ratio(%) in Congo (Republic)?
Your answer should be very brief. -14.12. In the year 2004, what is the difference between the Employment to population ratio(%) of Europe(developing only) and Employment to population ratio(%) of United Arab Emirates?
Your answer should be compact. 3.48. In the year 2004, what is the difference between the Employment to population ratio(%) in Armenia and Employment to population ratio(%) in Congo (Republic)?
Your answer should be very brief. -23.5. In the year 2004, what is the difference between the Employment to population ratio(%) in Armenia and Employment to population ratio(%) in United Arab Emirates?
Your answer should be very brief. -5.9. What is the ratio of the Employment to population ratio(%) in Europe(developing only) in 1997 to that in 1998?
Offer a terse response. 1.03. What is the ratio of the Employment to population ratio(%) in Armenia in 1997 to that in 1998?
Give a very brief answer. 0.97. What is the ratio of the Employment to population ratio(%) in Congo (Republic) in 1997 to that in 1998?
Keep it short and to the point. 0.99. What is the ratio of the Employment to population ratio(%) in United Arab Emirates in 1997 to that in 1998?
Provide a succinct answer. 1.06. What is the ratio of the Employment to population ratio(%) of Europe(developing only) in 1997 to that in 1999?
Provide a succinct answer. 1.03. What is the ratio of the Employment to population ratio(%) in Armenia in 1997 to that in 1999?
Provide a succinct answer. 0.98. What is the ratio of the Employment to population ratio(%) in United Arab Emirates in 1997 to that in 1999?
Make the answer very short. 1.06. What is the ratio of the Employment to population ratio(%) of Europe(developing only) in 1997 to that in 2000?
Your answer should be compact. 1.09. What is the ratio of the Employment to population ratio(%) of Armenia in 1997 to that in 2000?
Offer a very short reply. 0.96. What is the ratio of the Employment to population ratio(%) in Congo (Republic) in 1997 to that in 2000?
Keep it short and to the point. 0.99. What is the ratio of the Employment to population ratio(%) in United Arab Emirates in 1997 to that in 2000?
Your answer should be compact. 0.96. What is the ratio of the Employment to population ratio(%) in Europe(developing only) in 1997 to that in 2001?
Give a very brief answer. 1.1. What is the ratio of the Employment to population ratio(%) in Armenia in 1997 to that in 2001?
Provide a succinct answer. 1.3. What is the ratio of the Employment to population ratio(%) of United Arab Emirates in 1997 to that in 2001?
Keep it short and to the point. 1.02. What is the ratio of the Employment to population ratio(%) of Europe(developing only) in 1997 to that in 2002?
Offer a terse response. 1.13. What is the ratio of the Employment to population ratio(%) of Armenia in 1997 to that in 2002?
Ensure brevity in your answer.  1.77. What is the ratio of the Employment to population ratio(%) of Congo (Republic) in 1997 to that in 2002?
Your answer should be compact. 0.99. What is the ratio of the Employment to population ratio(%) of Europe(developing only) in 1997 to that in 2003?
Provide a short and direct response. 1.18. What is the ratio of the Employment to population ratio(%) in Armenia in 1997 to that in 2003?
Offer a very short reply. 2.02. What is the ratio of the Employment to population ratio(%) in Congo (Republic) in 1997 to that in 2003?
Keep it short and to the point. 1. What is the ratio of the Employment to population ratio(%) in United Arab Emirates in 1997 to that in 2003?
Your response must be concise. 0.93. What is the ratio of the Employment to population ratio(%) of Europe(developing only) in 1997 to that in 2004?
Make the answer very short. 1.19. What is the ratio of the Employment to population ratio(%) of Armenia in 1997 to that in 2004?
Give a very brief answer. 1.67. What is the ratio of the Employment to population ratio(%) of United Arab Emirates in 1997 to that in 2004?
Your response must be concise. 0.91. What is the ratio of the Employment to population ratio(%) in United Arab Emirates in 1998 to that in 1999?
Ensure brevity in your answer.  1. What is the ratio of the Employment to population ratio(%) of Europe(developing only) in 1998 to that in 2000?
Make the answer very short. 1.06. What is the ratio of the Employment to population ratio(%) in Armenia in 1998 to that in 2000?
Provide a succinct answer. 0.98. What is the ratio of the Employment to population ratio(%) of United Arab Emirates in 1998 to that in 2000?
Offer a terse response. 0.9. What is the ratio of the Employment to population ratio(%) of Europe(developing only) in 1998 to that in 2001?
Provide a short and direct response. 1.08. What is the ratio of the Employment to population ratio(%) in Armenia in 1998 to that in 2001?
Ensure brevity in your answer.  1.34. What is the ratio of the Employment to population ratio(%) in Congo (Republic) in 1998 to that in 2001?
Offer a terse response. 1. What is the ratio of the Employment to population ratio(%) of United Arab Emirates in 1998 to that in 2001?
Your answer should be compact. 0.96. What is the ratio of the Employment to population ratio(%) in Europe(developing only) in 1998 to that in 2002?
Keep it short and to the point. 1.1. What is the ratio of the Employment to population ratio(%) in Armenia in 1998 to that in 2002?
Offer a very short reply. 1.82. What is the ratio of the Employment to population ratio(%) in Congo (Republic) in 1998 to that in 2002?
Your answer should be compact. 1. What is the ratio of the Employment to population ratio(%) in United Arab Emirates in 1998 to that in 2002?
Give a very brief answer. 0.94. What is the ratio of the Employment to population ratio(%) of Europe(developing only) in 1998 to that in 2003?
Offer a terse response. 1.15. What is the ratio of the Employment to population ratio(%) of Armenia in 1998 to that in 2003?
Offer a terse response. 2.07. What is the ratio of the Employment to population ratio(%) of United Arab Emirates in 1998 to that in 2003?
Provide a short and direct response. 0.88. What is the ratio of the Employment to population ratio(%) in Europe(developing only) in 1998 to that in 2004?
Your response must be concise. 1.16. What is the ratio of the Employment to population ratio(%) in Armenia in 1998 to that in 2004?
Your response must be concise. 1.72. What is the ratio of the Employment to population ratio(%) in United Arab Emirates in 1998 to that in 2004?
Your answer should be very brief. 0.86. What is the ratio of the Employment to population ratio(%) of Europe(developing only) in 1999 to that in 2000?
Provide a succinct answer. 1.06. What is the ratio of the Employment to population ratio(%) in Armenia in 1999 to that in 2000?
Keep it short and to the point. 0.98. What is the ratio of the Employment to population ratio(%) in United Arab Emirates in 1999 to that in 2000?
Your answer should be compact. 0.9. What is the ratio of the Employment to population ratio(%) in Europe(developing only) in 1999 to that in 2001?
Your answer should be very brief. 1.08. What is the ratio of the Employment to population ratio(%) of Armenia in 1999 to that in 2001?
Provide a succinct answer. 1.33. What is the ratio of the Employment to population ratio(%) of Congo (Republic) in 1999 to that in 2001?
Provide a succinct answer. 0.99. What is the ratio of the Employment to population ratio(%) in United Arab Emirates in 1999 to that in 2001?
Your response must be concise. 0.96. What is the ratio of the Employment to population ratio(%) in Europe(developing only) in 1999 to that in 2002?
Your answer should be very brief. 1.1. What is the ratio of the Employment to population ratio(%) of Armenia in 1999 to that in 2002?
Make the answer very short. 1.81. What is the ratio of the Employment to population ratio(%) in Congo (Republic) in 1999 to that in 2002?
Your answer should be very brief. 0.99. What is the ratio of the Employment to population ratio(%) of United Arab Emirates in 1999 to that in 2002?
Give a very brief answer. 0.94. What is the ratio of the Employment to population ratio(%) of Europe(developing only) in 1999 to that in 2003?
Provide a succinct answer. 1.15. What is the ratio of the Employment to population ratio(%) of Armenia in 1999 to that in 2003?
Offer a terse response. 2.07. What is the ratio of the Employment to population ratio(%) of United Arab Emirates in 1999 to that in 2003?
Your answer should be very brief. 0.88. What is the ratio of the Employment to population ratio(%) of Europe(developing only) in 1999 to that in 2004?
Make the answer very short. 1.16. What is the ratio of the Employment to population ratio(%) in Armenia in 1999 to that in 2004?
Provide a succinct answer. 1.71. What is the ratio of the Employment to population ratio(%) of United Arab Emirates in 1999 to that in 2004?
Ensure brevity in your answer.  0.86. What is the ratio of the Employment to population ratio(%) in Europe(developing only) in 2000 to that in 2001?
Offer a very short reply. 1.01. What is the ratio of the Employment to population ratio(%) of Armenia in 2000 to that in 2001?
Offer a very short reply. 1.36. What is the ratio of the Employment to population ratio(%) of United Arab Emirates in 2000 to that in 2001?
Give a very brief answer. 1.06. What is the ratio of the Employment to population ratio(%) of Europe(developing only) in 2000 to that in 2002?
Keep it short and to the point. 1.04. What is the ratio of the Employment to population ratio(%) in Armenia in 2000 to that in 2002?
Offer a terse response. 1.85. What is the ratio of the Employment to population ratio(%) of United Arab Emirates in 2000 to that in 2002?
Offer a very short reply. 1.04. What is the ratio of the Employment to population ratio(%) of Europe(developing only) in 2000 to that in 2003?
Offer a very short reply. 1.08. What is the ratio of the Employment to population ratio(%) of Armenia in 2000 to that in 2003?
Give a very brief answer. 2.11. What is the ratio of the Employment to population ratio(%) in Europe(developing only) in 2000 to that in 2004?
Provide a short and direct response. 1.09. What is the ratio of the Employment to population ratio(%) of Armenia in 2000 to that in 2004?
Your response must be concise. 1.75. What is the ratio of the Employment to population ratio(%) of United Arab Emirates in 2000 to that in 2004?
Your answer should be compact. 0.95. What is the ratio of the Employment to population ratio(%) of Europe(developing only) in 2001 to that in 2002?
Give a very brief answer. 1.02. What is the ratio of the Employment to population ratio(%) of Armenia in 2001 to that in 2002?
Keep it short and to the point. 1.36. What is the ratio of the Employment to population ratio(%) in Congo (Republic) in 2001 to that in 2002?
Keep it short and to the point. 1. What is the ratio of the Employment to population ratio(%) of United Arab Emirates in 2001 to that in 2002?
Give a very brief answer. 0.98. What is the ratio of the Employment to population ratio(%) in Europe(developing only) in 2001 to that in 2003?
Ensure brevity in your answer.  1.07. What is the ratio of the Employment to population ratio(%) of Armenia in 2001 to that in 2003?
Offer a terse response. 1.55. What is the ratio of the Employment to population ratio(%) in Congo (Republic) in 2001 to that in 2003?
Provide a short and direct response. 1. What is the ratio of the Employment to population ratio(%) in United Arab Emirates in 2001 to that in 2003?
Give a very brief answer. 0.91. What is the ratio of the Employment to population ratio(%) of Europe(developing only) in 2001 to that in 2004?
Make the answer very short. 1.07. What is the ratio of the Employment to population ratio(%) of Armenia in 2001 to that in 2004?
Give a very brief answer. 1.28. What is the ratio of the Employment to population ratio(%) of United Arab Emirates in 2001 to that in 2004?
Offer a very short reply. 0.9. What is the ratio of the Employment to population ratio(%) of Europe(developing only) in 2002 to that in 2003?
Provide a short and direct response. 1.04. What is the ratio of the Employment to population ratio(%) of Armenia in 2002 to that in 2003?
Your answer should be compact. 1.14. What is the ratio of the Employment to population ratio(%) of Congo (Republic) in 2002 to that in 2003?
Provide a short and direct response. 1.01. What is the ratio of the Employment to population ratio(%) in United Arab Emirates in 2002 to that in 2003?
Make the answer very short. 0.93. What is the ratio of the Employment to population ratio(%) in Europe(developing only) in 2002 to that in 2004?
Your answer should be very brief. 1.05. What is the ratio of the Employment to population ratio(%) in Armenia in 2002 to that in 2004?
Offer a very short reply. 0.94. What is the ratio of the Employment to population ratio(%) of Congo (Republic) in 2002 to that in 2004?
Provide a succinct answer. 1. What is the ratio of the Employment to population ratio(%) of United Arab Emirates in 2002 to that in 2004?
Keep it short and to the point. 0.91. What is the ratio of the Employment to population ratio(%) of Europe(developing only) in 2003 to that in 2004?
Offer a very short reply. 1.01. What is the ratio of the Employment to population ratio(%) of Armenia in 2003 to that in 2004?
Keep it short and to the point. 0.83. What is the ratio of the Employment to population ratio(%) in United Arab Emirates in 2003 to that in 2004?
Your response must be concise. 0.98. What is the difference between the highest and the second highest Employment to population ratio(%) of Europe(developing only)?
Offer a terse response. 0.75. What is the difference between the highest and the second highest Employment to population ratio(%) in Armenia?
Your answer should be very brief. 0.5. What is the difference between the highest and the second highest Employment to population ratio(%) in Congo (Republic)?
Offer a terse response. 0. What is the difference between the highest and the second highest Employment to population ratio(%) in United Arab Emirates?
Offer a very short reply. 0.4. What is the difference between the highest and the lowest Employment to population ratio(%) in Europe(developing only)?
Keep it short and to the point. 4.76. What is the difference between the highest and the lowest Employment to population ratio(%) in Armenia?
Ensure brevity in your answer.  14.9. What is the difference between the highest and the lowest Employment to population ratio(%) of Congo (Republic)?
Provide a succinct answer. 0.3. What is the difference between the highest and the lowest Employment to population ratio(%) of United Arab Emirates?
Ensure brevity in your answer.  3.1. 